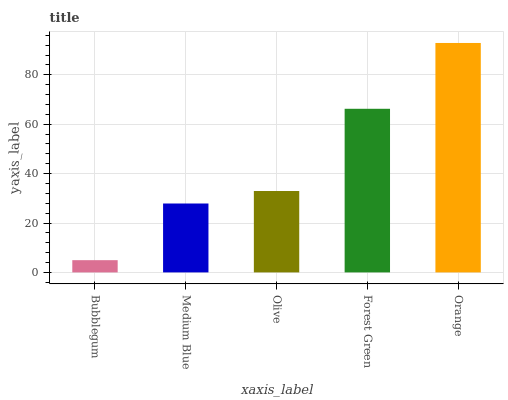Is Bubblegum the minimum?
Answer yes or no. Yes. Is Orange the maximum?
Answer yes or no. Yes. Is Medium Blue the minimum?
Answer yes or no. No. Is Medium Blue the maximum?
Answer yes or no. No. Is Medium Blue greater than Bubblegum?
Answer yes or no. Yes. Is Bubblegum less than Medium Blue?
Answer yes or no. Yes. Is Bubblegum greater than Medium Blue?
Answer yes or no. No. Is Medium Blue less than Bubblegum?
Answer yes or no. No. Is Olive the high median?
Answer yes or no. Yes. Is Olive the low median?
Answer yes or no. Yes. Is Forest Green the high median?
Answer yes or no. No. Is Orange the low median?
Answer yes or no. No. 